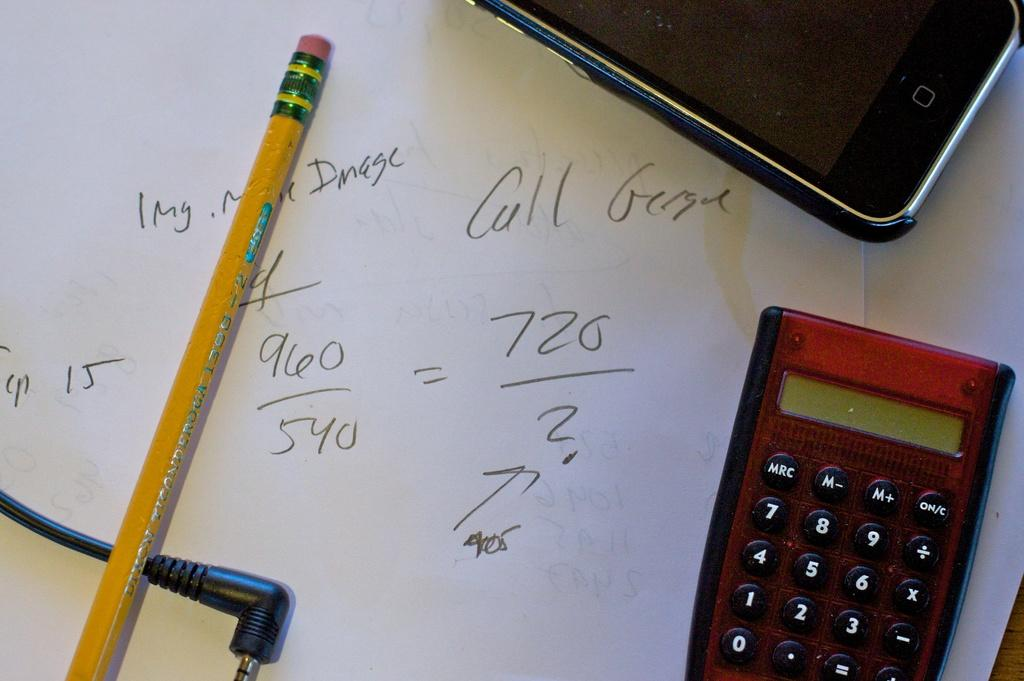<image>
Render a clear and concise summary of the photo. Notes written in pencil include a notation of 1 mg. 